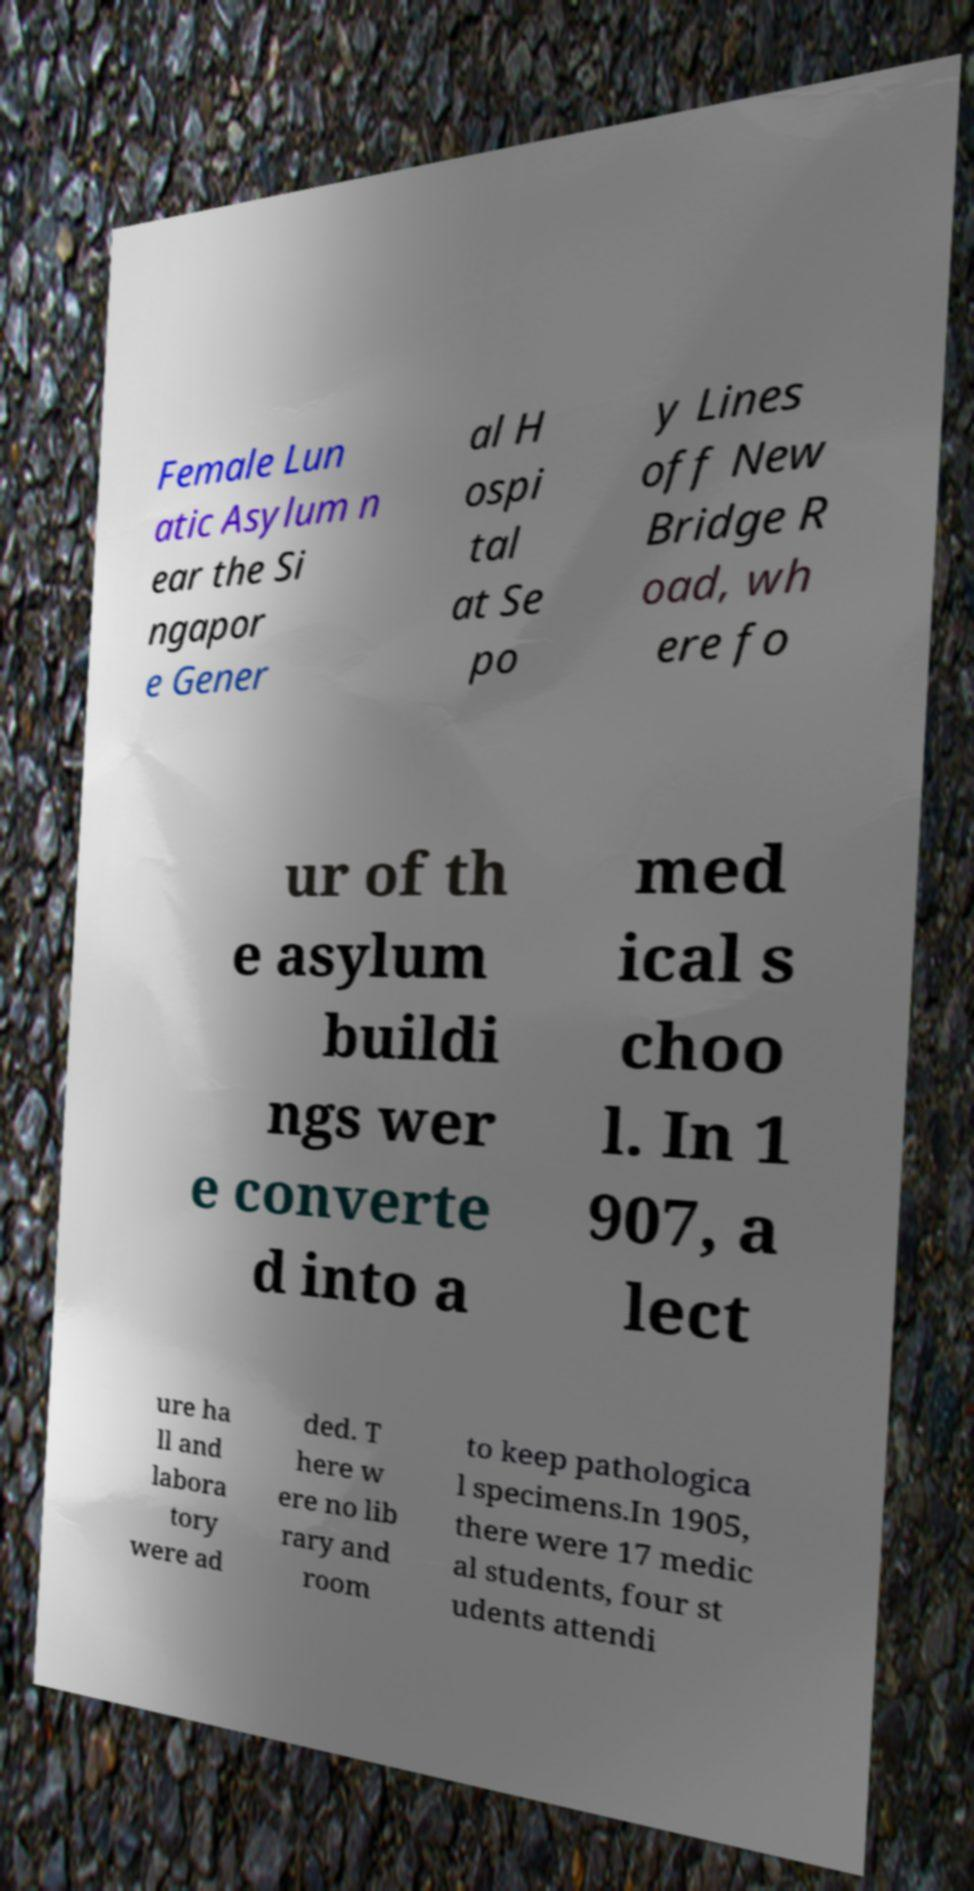Please identify and transcribe the text found in this image. Female Lun atic Asylum n ear the Si ngapor e Gener al H ospi tal at Se po y Lines off New Bridge R oad, wh ere fo ur of th e asylum buildi ngs wer e converte d into a med ical s choo l. In 1 907, a lect ure ha ll and labora tory were ad ded. T here w ere no lib rary and room to keep pathologica l specimens.In 1905, there were 17 medic al students, four st udents attendi 